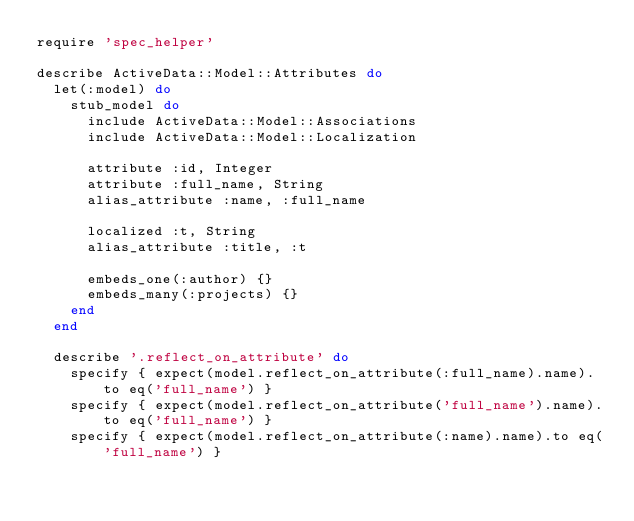<code> <loc_0><loc_0><loc_500><loc_500><_Ruby_>require 'spec_helper'

describe ActiveData::Model::Attributes do
  let(:model) do
    stub_model do
      include ActiveData::Model::Associations
      include ActiveData::Model::Localization

      attribute :id, Integer
      attribute :full_name, String
      alias_attribute :name, :full_name

      localized :t, String
      alias_attribute :title, :t

      embeds_one(:author) {}
      embeds_many(:projects) {}
    end
  end

  describe '.reflect_on_attribute' do
    specify { expect(model.reflect_on_attribute(:full_name).name).to eq('full_name') }
    specify { expect(model.reflect_on_attribute('full_name').name).to eq('full_name') }
    specify { expect(model.reflect_on_attribute(:name).name).to eq('full_name') }</code> 